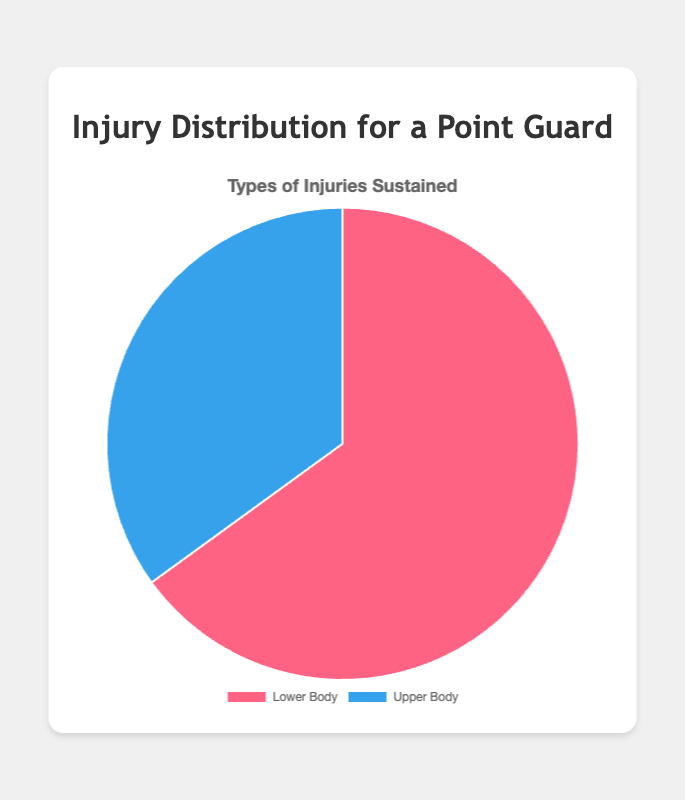What's the percentage of lower body injuries? The chart's data shows that lower body injuries constitute 65% of the total injuries.
Answer: 65% What's the percentage difference between lower body and upper body injuries? The percentage of lower body injuries is 65% and upper body injuries is 35%. The difference is 65% - 35% = 30%.
Answer: 30% Which type of injury occurs more frequently, ankle sprains or wrist fractures? From the injury details, ankle sprains occur with a frequency of 35, while wrist fractures have a frequency of 10. Ankle sprains are more frequent.
Answer: Ankle sprains How many percentage points more are lower body injuries compared to upper body injuries? Lower body injuries account for 65% and upper body injuries for 35%. The difference is 65 - 35 = 30 percentage points.
Answer: 30 What is the combined percentage of lower body and upper body injuries? The combined percentage of both types of injuries equals 100%, as the chart covers the entire injury distribution.
Answer: 100% How does the frequency of knee ligament tears compare to the frequency of hand contusions? The frequency of knee ligament tears is 20, while the frequency of hand contusions is 10. Knee ligament tears are more frequent.
Answer: Knee ligament tears Which section of the pie chart is larger, the one representing lower body injuries or the one representing upper body injuries? The lower body injuries section (65%) is larger than the upper body injuries section (35%).
Answer: Lower body injuries What are the three upper body injuries and their respective frequencies? The upper body injuries listed are shoulder dislocations (15), wrist fractures (10), and hand contusions (10).
Answer: Shoulder dislocations (15), wrist fractures (10), hand contusions (10) Add the frequencies of hamstring strains and wrist fractures. What do you get? The frequency of hamstring strains is 10, and the frequency of wrist fractures is 10. Adding them gives 10 + 10 = 20.
Answer: 20 If you add the frequencies of all lower body injuries, what is the total frequency? Adding the frequencies: ankle sprains (35) + knee ligament tears (20) + hamstring strains (10) equals 35 + 20 + 10 = 65.
Answer: 65 